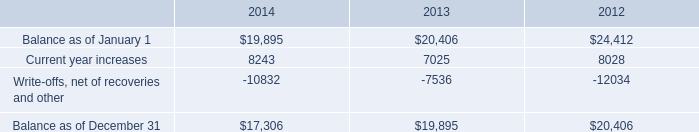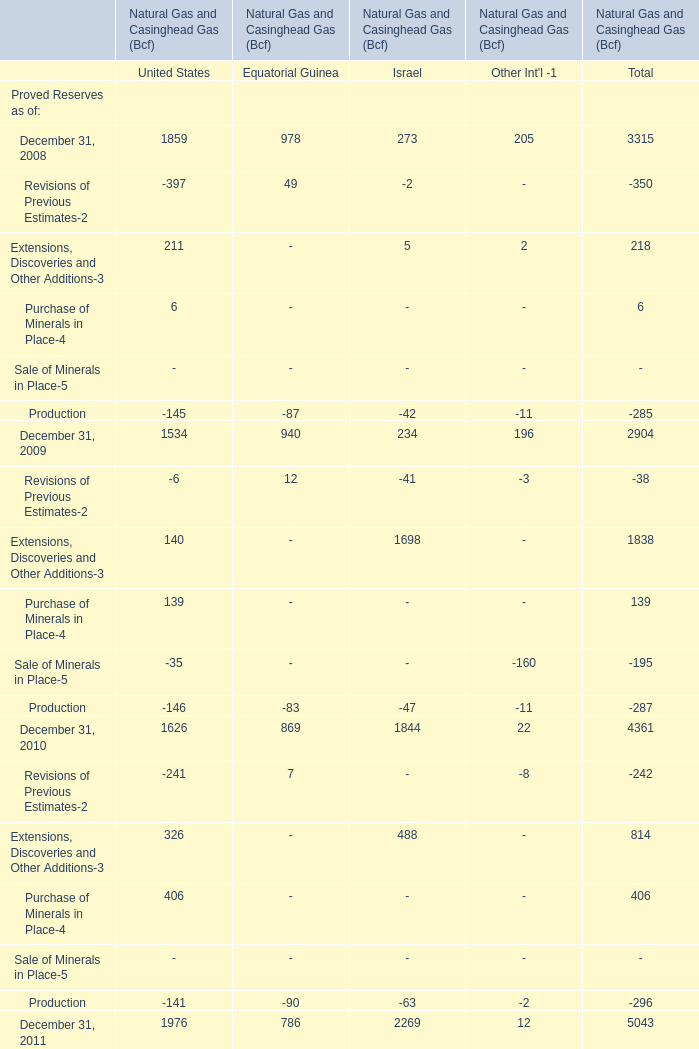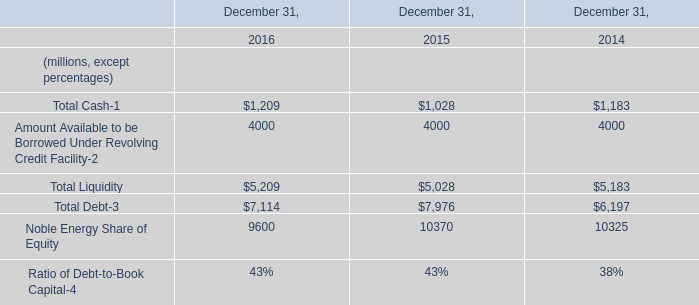What is the average amount of Current year increases of 2014, and Noble Energy Share of Equity of December 31, 2016 ? 
Computations: ((8243.0 + 9600.0) / 2)
Answer: 8921.5. 